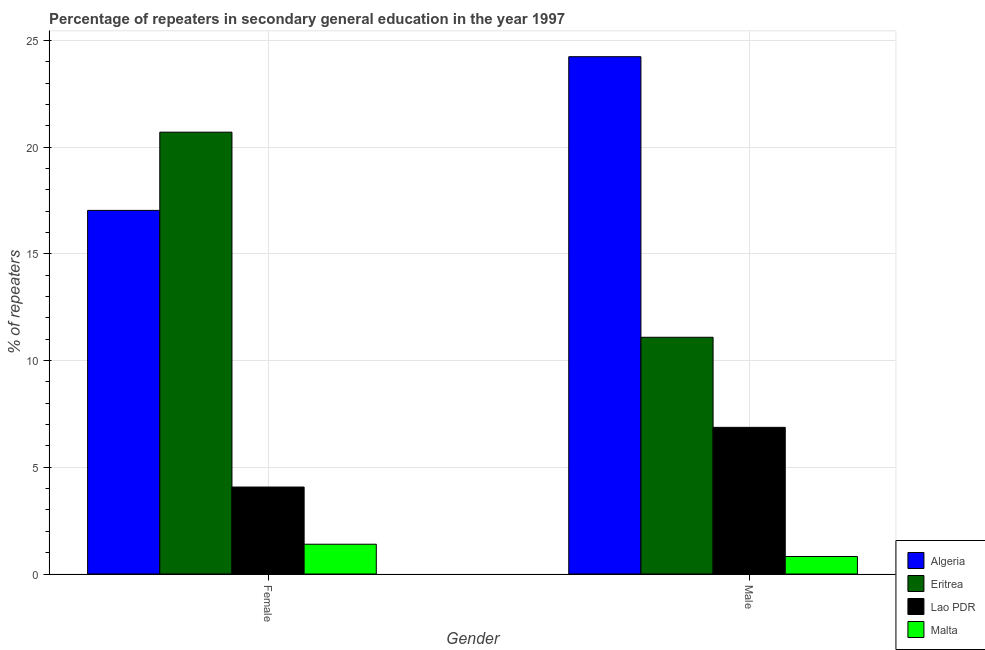How many different coloured bars are there?
Give a very brief answer. 4. Are the number of bars per tick equal to the number of legend labels?
Ensure brevity in your answer.  Yes. Are the number of bars on each tick of the X-axis equal?
Provide a short and direct response. Yes. How many bars are there on the 2nd tick from the left?
Offer a terse response. 4. How many bars are there on the 2nd tick from the right?
Ensure brevity in your answer.  4. What is the percentage of female repeaters in Algeria?
Offer a terse response. 17.04. Across all countries, what is the maximum percentage of male repeaters?
Your answer should be compact. 24.24. Across all countries, what is the minimum percentage of female repeaters?
Your answer should be very brief. 1.4. In which country was the percentage of male repeaters maximum?
Offer a very short reply. Algeria. In which country was the percentage of female repeaters minimum?
Provide a short and direct response. Malta. What is the total percentage of female repeaters in the graph?
Your answer should be compact. 43.21. What is the difference between the percentage of female repeaters in Malta and that in Lao PDR?
Your response must be concise. -2.68. What is the difference between the percentage of female repeaters in Algeria and the percentage of male repeaters in Lao PDR?
Your answer should be compact. 10.17. What is the average percentage of male repeaters per country?
Give a very brief answer. 10.76. What is the difference between the percentage of female repeaters and percentage of male repeaters in Algeria?
Your answer should be very brief. -7.2. In how many countries, is the percentage of male repeaters greater than 11 %?
Offer a very short reply. 2. What is the ratio of the percentage of female repeaters in Malta to that in Algeria?
Offer a very short reply. 0.08. Is the percentage of female repeaters in Eritrea less than that in Malta?
Your answer should be very brief. No. What does the 3rd bar from the left in Female represents?
Provide a short and direct response. Lao PDR. What does the 1st bar from the right in Male represents?
Your answer should be compact. Malta. What is the difference between two consecutive major ticks on the Y-axis?
Provide a succinct answer. 5. Are the values on the major ticks of Y-axis written in scientific E-notation?
Give a very brief answer. No. Does the graph contain any zero values?
Offer a terse response. No. How many legend labels are there?
Make the answer very short. 4. What is the title of the graph?
Give a very brief answer. Percentage of repeaters in secondary general education in the year 1997. What is the label or title of the Y-axis?
Provide a short and direct response. % of repeaters. What is the % of repeaters of Algeria in Female?
Offer a very short reply. 17.04. What is the % of repeaters of Eritrea in Female?
Ensure brevity in your answer.  20.7. What is the % of repeaters in Lao PDR in Female?
Offer a very short reply. 4.08. What is the % of repeaters of Malta in Female?
Keep it short and to the point. 1.4. What is the % of repeaters of Algeria in Male?
Your answer should be very brief. 24.24. What is the % of repeaters of Eritrea in Male?
Your answer should be compact. 11.09. What is the % of repeaters in Lao PDR in Male?
Your answer should be compact. 6.87. What is the % of repeaters in Malta in Male?
Your response must be concise. 0.82. Across all Gender, what is the maximum % of repeaters of Algeria?
Give a very brief answer. 24.24. Across all Gender, what is the maximum % of repeaters of Eritrea?
Offer a terse response. 20.7. Across all Gender, what is the maximum % of repeaters of Lao PDR?
Your response must be concise. 6.87. Across all Gender, what is the maximum % of repeaters in Malta?
Make the answer very short. 1.4. Across all Gender, what is the minimum % of repeaters in Algeria?
Give a very brief answer. 17.04. Across all Gender, what is the minimum % of repeaters in Eritrea?
Make the answer very short. 11.09. Across all Gender, what is the minimum % of repeaters in Lao PDR?
Offer a very short reply. 4.08. Across all Gender, what is the minimum % of repeaters in Malta?
Your answer should be compact. 0.82. What is the total % of repeaters of Algeria in the graph?
Your response must be concise. 41.28. What is the total % of repeaters in Eritrea in the graph?
Your answer should be compact. 31.79. What is the total % of repeaters in Lao PDR in the graph?
Give a very brief answer. 10.95. What is the total % of repeaters of Malta in the graph?
Ensure brevity in your answer.  2.21. What is the difference between the % of repeaters in Algeria in Female and that in Male?
Your answer should be very brief. -7.2. What is the difference between the % of repeaters of Eritrea in Female and that in Male?
Offer a very short reply. 9.61. What is the difference between the % of repeaters in Lao PDR in Female and that in Male?
Your response must be concise. -2.8. What is the difference between the % of repeaters in Malta in Female and that in Male?
Offer a very short reply. 0.58. What is the difference between the % of repeaters in Algeria in Female and the % of repeaters in Eritrea in Male?
Provide a short and direct response. 5.94. What is the difference between the % of repeaters in Algeria in Female and the % of repeaters in Lao PDR in Male?
Ensure brevity in your answer.  10.16. What is the difference between the % of repeaters of Algeria in Female and the % of repeaters of Malta in Male?
Offer a very short reply. 16.22. What is the difference between the % of repeaters of Eritrea in Female and the % of repeaters of Lao PDR in Male?
Make the answer very short. 13.83. What is the difference between the % of repeaters in Eritrea in Female and the % of repeaters in Malta in Male?
Give a very brief answer. 19.88. What is the difference between the % of repeaters of Lao PDR in Female and the % of repeaters of Malta in Male?
Give a very brief answer. 3.26. What is the average % of repeaters of Algeria per Gender?
Offer a very short reply. 20.64. What is the average % of repeaters in Eritrea per Gender?
Offer a very short reply. 15.9. What is the average % of repeaters of Lao PDR per Gender?
Keep it short and to the point. 5.47. What is the average % of repeaters in Malta per Gender?
Offer a very short reply. 1.11. What is the difference between the % of repeaters of Algeria and % of repeaters of Eritrea in Female?
Offer a very short reply. -3.67. What is the difference between the % of repeaters in Algeria and % of repeaters in Lao PDR in Female?
Keep it short and to the point. 12.96. What is the difference between the % of repeaters of Algeria and % of repeaters of Malta in Female?
Your answer should be very brief. 15.64. What is the difference between the % of repeaters in Eritrea and % of repeaters in Lao PDR in Female?
Offer a terse response. 16.63. What is the difference between the % of repeaters in Eritrea and % of repeaters in Malta in Female?
Offer a very short reply. 19.31. What is the difference between the % of repeaters in Lao PDR and % of repeaters in Malta in Female?
Ensure brevity in your answer.  2.68. What is the difference between the % of repeaters in Algeria and % of repeaters in Eritrea in Male?
Your response must be concise. 13.15. What is the difference between the % of repeaters in Algeria and % of repeaters in Lao PDR in Male?
Ensure brevity in your answer.  17.37. What is the difference between the % of repeaters in Algeria and % of repeaters in Malta in Male?
Offer a terse response. 23.42. What is the difference between the % of repeaters in Eritrea and % of repeaters in Lao PDR in Male?
Your answer should be very brief. 4.22. What is the difference between the % of repeaters of Eritrea and % of repeaters of Malta in Male?
Provide a short and direct response. 10.27. What is the difference between the % of repeaters in Lao PDR and % of repeaters in Malta in Male?
Provide a short and direct response. 6.05. What is the ratio of the % of repeaters in Algeria in Female to that in Male?
Give a very brief answer. 0.7. What is the ratio of the % of repeaters in Eritrea in Female to that in Male?
Give a very brief answer. 1.87. What is the ratio of the % of repeaters of Lao PDR in Female to that in Male?
Your answer should be compact. 0.59. What is the ratio of the % of repeaters of Malta in Female to that in Male?
Provide a succinct answer. 1.7. What is the difference between the highest and the second highest % of repeaters in Algeria?
Your response must be concise. 7.2. What is the difference between the highest and the second highest % of repeaters of Eritrea?
Offer a very short reply. 9.61. What is the difference between the highest and the second highest % of repeaters of Lao PDR?
Ensure brevity in your answer.  2.8. What is the difference between the highest and the second highest % of repeaters of Malta?
Your answer should be compact. 0.58. What is the difference between the highest and the lowest % of repeaters of Algeria?
Your answer should be compact. 7.2. What is the difference between the highest and the lowest % of repeaters in Eritrea?
Your answer should be compact. 9.61. What is the difference between the highest and the lowest % of repeaters in Lao PDR?
Your response must be concise. 2.8. What is the difference between the highest and the lowest % of repeaters in Malta?
Offer a very short reply. 0.58. 